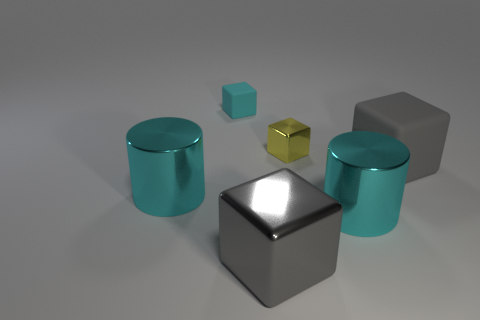What material is the tiny yellow block?
Your answer should be compact. Metal. What is the shape of the large cyan object to the right of the matte thing to the left of the yellow object?
Provide a succinct answer. Cylinder. How many other things are there of the same shape as the large gray matte thing?
Offer a very short reply. 3. Are there any cyan rubber cubes in front of the gray metallic block?
Make the answer very short. No. What is the color of the big metallic block?
Give a very brief answer. Gray. There is a small rubber object; is it the same color as the shiny cylinder right of the cyan matte cube?
Ensure brevity in your answer.  Yes. Is there a gray rubber cube of the same size as the gray metal thing?
Offer a very short reply. Yes. What is the gray object right of the tiny yellow block made of?
Offer a terse response. Rubber. Are there an equal number of yellow blocks that are right of the gray matte cube and cyan shiny objects behind the gray metal object?
Offer a terse response. No. Does the gray rubber thing that is behind the gray shiny block have the same size as the rubber block behind the big rubber block?
Your response must be concise. No. 